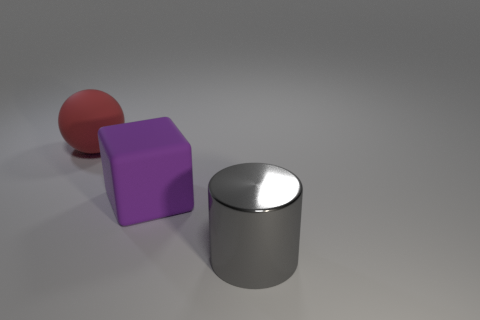Is there a big rubber ball that has the same color as the rubber block? no 